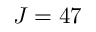<formula> <loc_0><loc_0><loc_500><loc_500>J = 4 7</formula> 